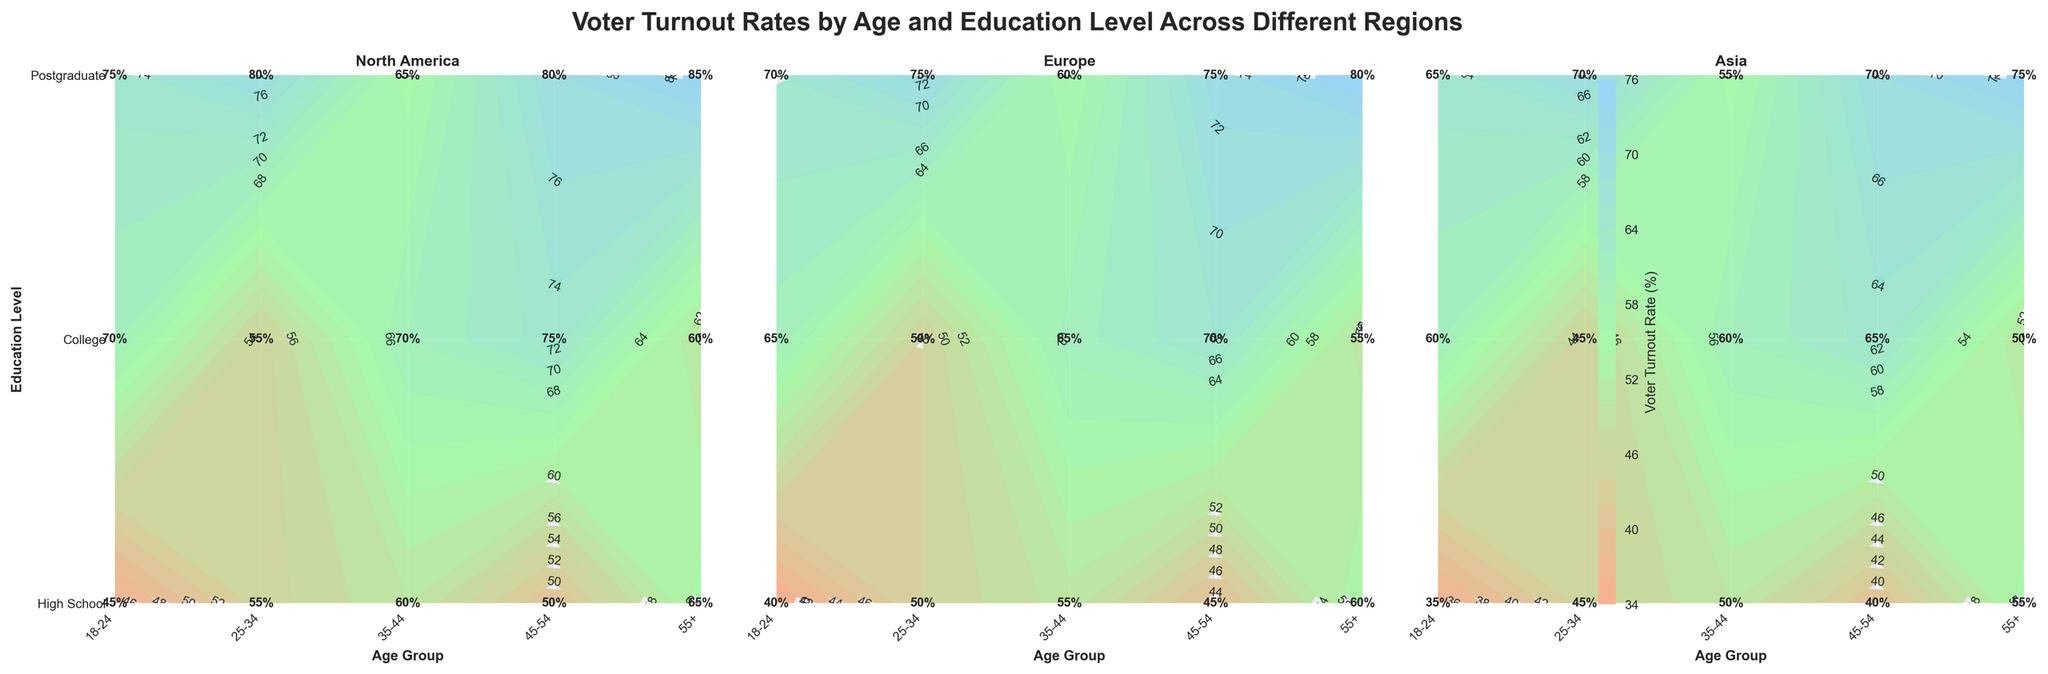What is the title of the figure? The title is located at the top of the figure and states the main focus of the plot.
Answer: Voter Turnout Rates by Age and Education Level Across Different Regions Which region shows the highest voter turnout rate for the age group 18-24 with a Postgraduate education level? Look at the uppermost contour labels for age 18-24 and Postgraduate in each region pane to find the highest value.
Answer: North America What is the voter turnout rate for individuals aged 35-44 with a High School education in Asia? Locate the 35-44 age group and High School education level in the "Asia" plot pane, then find the corresponding label.
Answer: 45% How does college education impact voter turnout rates across different age groups in Europe? Compare the voter turnout rates for each age group with College education in the Europe pane.
Answer: Higher age groups tend to have higher turnout rates, with rates increasing from 50% to 75% Which region has the least difference in voter turnout between high school and postgraduate education for the age group 45-54? Calculate the difference in voter turnout rates for the 45-54 age group between High School and Postgraduate in each region pane and find the smallest difference.
Answer: Europe What is the average voter turnout rate for North America across all age groups with a College education? Add the voter turnout rates for the College education level in North America for all age groups: (55 + 65 + 70 + 75 + 80), then divide by 5.
Answer: 69% Which age group in Asia has the lowest voter turnout rate overall? Identify the age group with the smallest voter turnout percentage in the Asia plot pane.
Answer: 18-24 Compare the voter turnout rates for individuals aged 55+ with College education between North America and Europe. Look at the 55+ age group and College education level in both North America and Europe panes and compare the values.
Answer: North America (80%) > Europe (75%) What is the general trend of voter turnout rates across age groups within each education level in Europe? Observe the rate changes across age groups within each education level in the Europe pane to identify trends.
Answer: Turnout rates generally increase with age within each education level How much higher is the voter turnout rate for Postgraduates aged 55+ in North America compared to those aged 18-24 in the same region? Subtract the voter turnout rate for Postgraduates aged 18-24 from that of those aged 55+ in North America.
Answer: 85% - 60% = 25% 